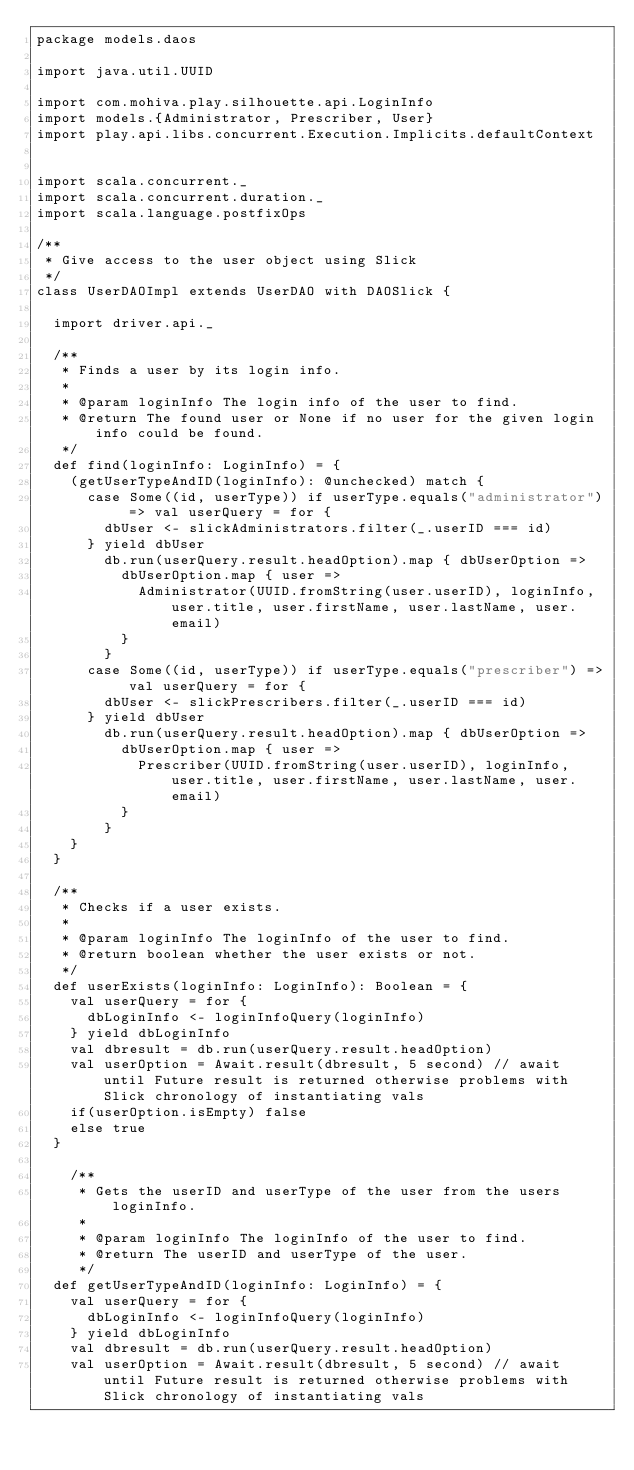<code> <loc_0><loc_0><loc_500><loc_500><_Scala_>package models.daos

import java.util.UUID

import com.mohiva.play.silhouette.api.LoginInfo
import models.{Administrator, Prescriber, User}
import play.api.libs.concurrent.Execution.Implicits.defaultContext


import scala.concurrent._
import scala.concurrent.duration._
import scala.language.postfixOps

/**
 * Give access to the user object using Slick
 */
class UserDAOImpl extends UserDAO with DAOSlick {

  import driver.api._

  /**
   * Finds a user by its login info.
   *
   * @param loginInfo The login info of the user to find.
   * @return The found user or None if no user for the given login info could be found.
   */
  def find(loginInfo: LoginInfo) = {
    (getUserTypeAndID(loginInfo): @unchecked) match {
      case Some((id, userType)) if userType.equals("administrator") => val userQuery = for {
        dbUser <- slickAdministrators.filter(_.userID === id)
      } yield dbUser
        db.run(userQuery.result.headOption).map { dbUserOption =>
          dbUserOption.map { user =>
            Administrator(UUID.fromString(user.userID), loginInfo, user.title, user.firstName, user.lastName, user.email)
          }
        }
      case Some((id, userType)) if userType.equals("prescriber") => val userQuery = for {
        dbUser <- slickPrescribers.filter(_.userID === id)
      } yield dbUser
        db.run(userQuery.result.headOption).map { dbUserOption =>
          dbUserOption.map { user =>
            Prescriber(UUID.fromString(user.userID), loginInfo, user.title, user.firstName, user.lastName, user.email)
          }
        }
    }
  }

  /**
   * Checks if a user exists.
   *
   * @param loginInfo The loginInfo of the user to find.
   * @return boolean whether the user exists or not.
   */
  def userExists(loginInfo: LoginInfo): Boolean = {
    val userQuery = for {
      dbLoginInfo <- loginInfoQuery(loginInfo)
    } yield dbLoginInfo
    val dbresult = db.run(userQuery.result.headOption)
    val userOption = Await.result(dbresult, 5 second) // await until Future result is returned otherwise problems with Slick chronology of instantiating vals
    if(userOption.isEmpty) false
    else true
  }

    /**
     * Gets the userID and userType of the user from the users loginInfo.
     *
     * @param loginInfo The loginInfo of the user to find.
     * @return The userID and userType of the user.
     */
  def getUserTypeAndID(loginInfo: LoginInfo) = {
    val userQuery = for {
      dbLoginInfo <- loginInfoQuery(loginInfo)
    } yield dbLoginInfo
    val dbresult = db.run(userQuery.result.headOption)
    val userOption = Await.result(dbresult, 5 second) // await until Future result is returned otherwise problems with Slick chronology of instantiating vals</code> 